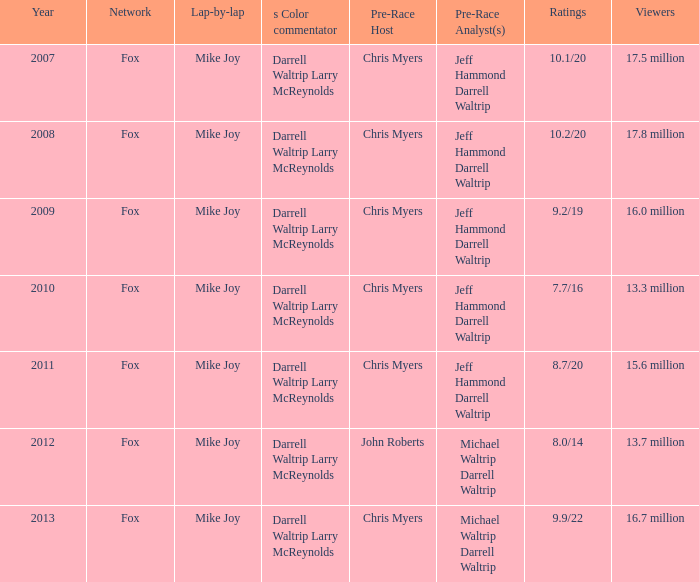7 million? 2012.0. 